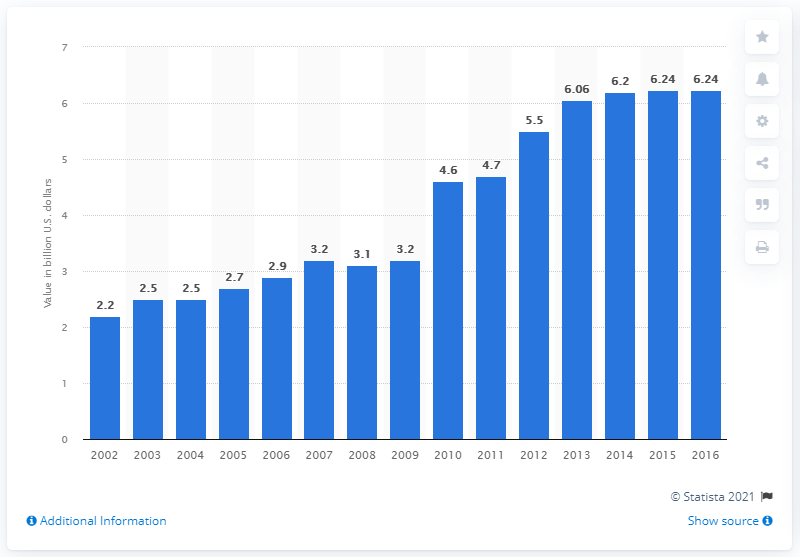Identify some key points in this picture. According to the data, the value of the U.S. product shipment of yogurt in 2016 was 6.24 billion dollars. 